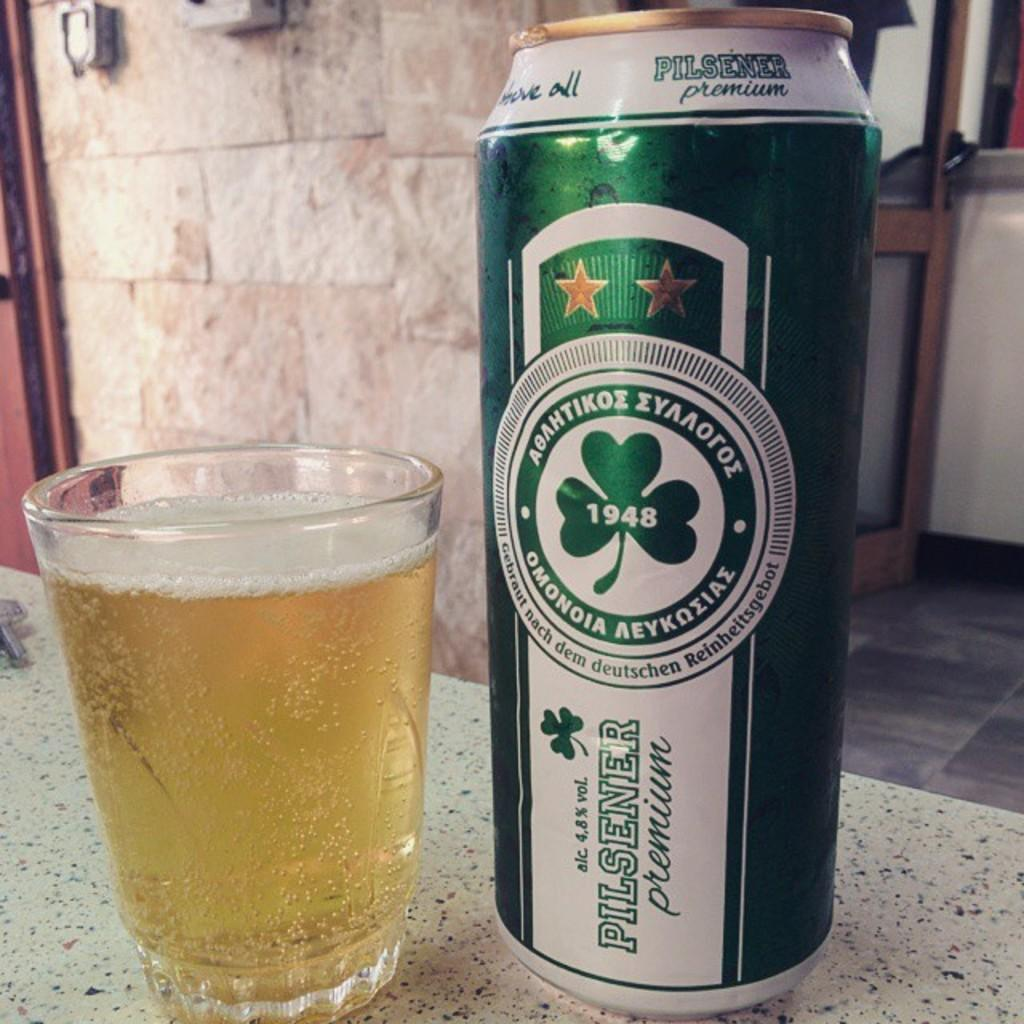<image>
Share a concise interpretation of the image provided. A can of Pilsner premium ale next to a glass of what is presumably the same. 